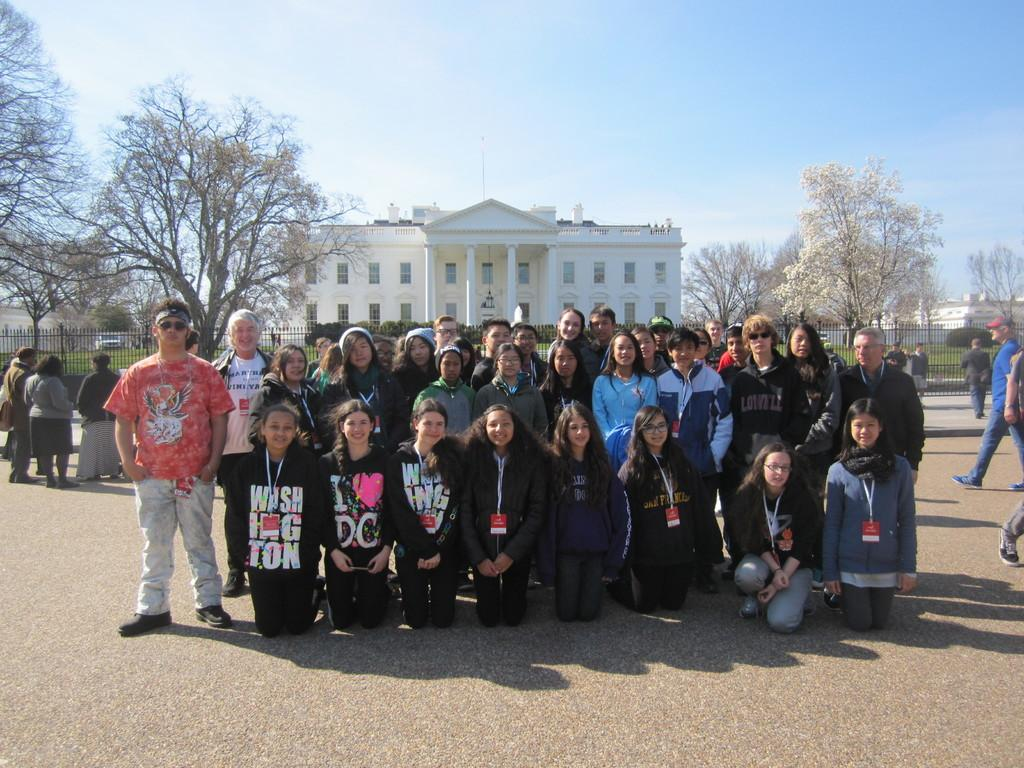Who or what can be seen in the image? There are people in the image. What type of structures are visible in the image? There are buildings in the image. What natural elements can be seen in the image? There are trees and grass in the image. What type of transportation is present in the image? There are no specific modes of transportation mentioned, but there are vehicles visible. What architectural features can be seen in the image? There are windows and a fence in the image. What is visible in the background of the image? The sky is visible in the background of the image. What type of jewel is being used to decorate the railway in the image? There is no railway or jewel present in the image. What is the name of the person depicted in the image? The image does not show a specific person, so it is not possible to determine their name. 